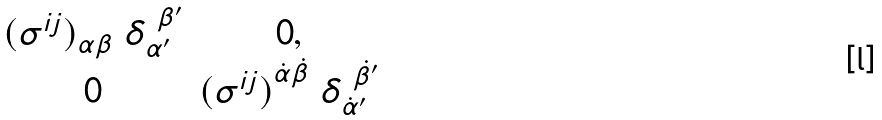Convert formula to latex. <formula><loc_0><loc_0><loc_500><loc_500>\begin{matrix} { ( \sigma ^ { i j } ) } _ { { \alpha } { \beta } } \ \delta _ { \alpha ^ { \prime } } ^ { \ \beta ^ { \prime } } & 0 , \\ 0 & { ( \sigma ^ { i j } ) } ^ { { \dot { \alpha } } { \dot { \beta } } } \ \delta _ { \dot { \alpha } ^ { \prime } } ^ { \ { \dot { \beta } ^ { \prime } } } \\ \end{matrix}</formula> 